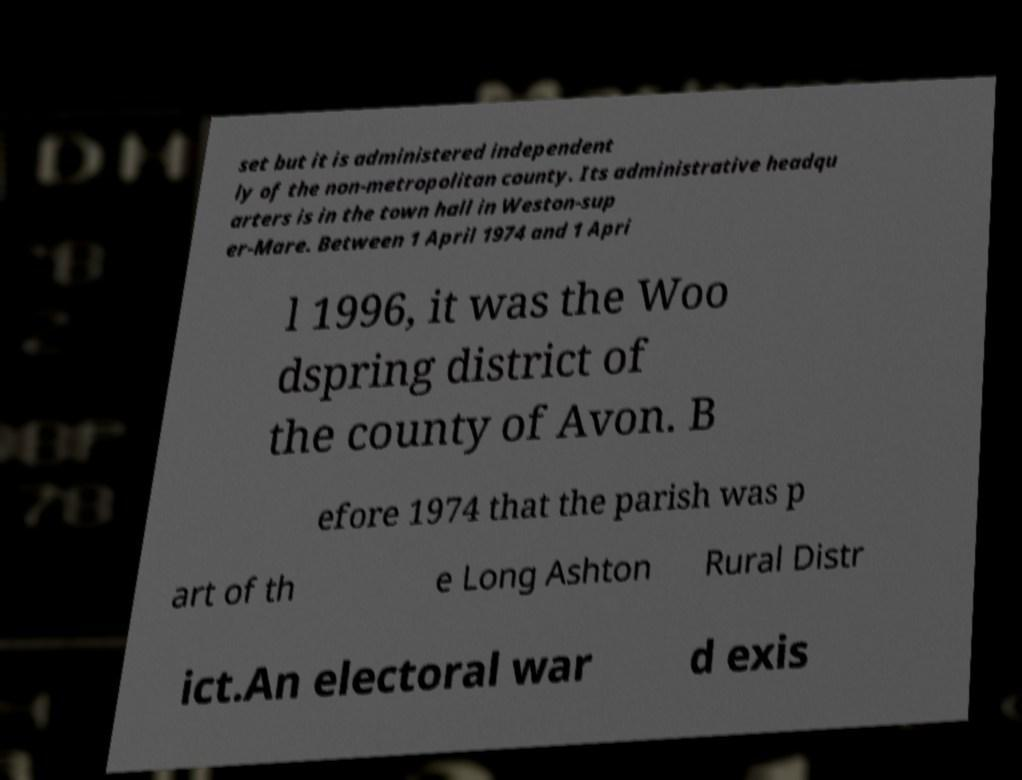What messages or text are displayed in this image? I need them in a readable, typed format. set but it is administered independent ly of the non-metropolitan county. Its administrative headqu arters is in the town hall in Weston-sup er-Mare. Between 1 April 1974 and 1 Apri l 1996, it was the Woo dspring district of the county of Avon. B efore 1974 that the parish was p art of th e Long Ashton Rural Distr ict.An electoral war d exis 